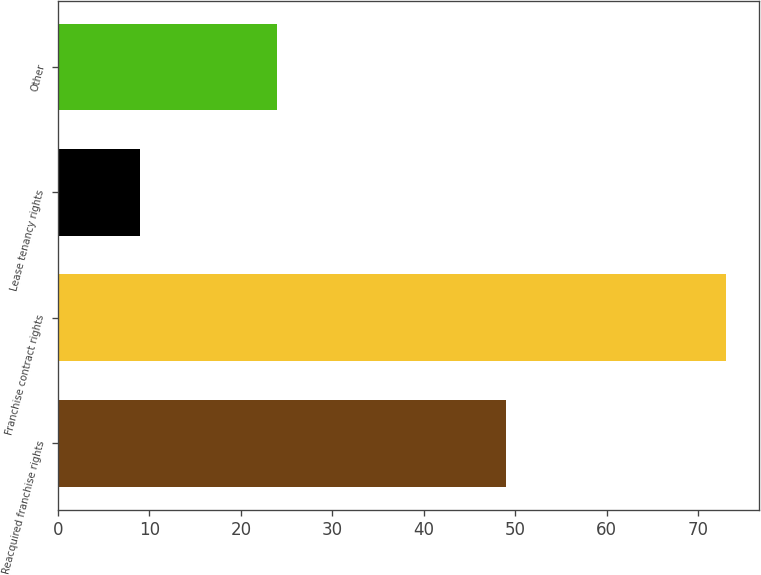<chart> <loc_0><loc_0><loc_500><loc_500><bar_chart><fcel>Reacquired franchise rights<fcel>Franchise contract rights<fcel>Lease tenancy rights<fcel>Other<nl><fcel>49<fcel>73<fcel>9<fcel>24<nl></chart> 